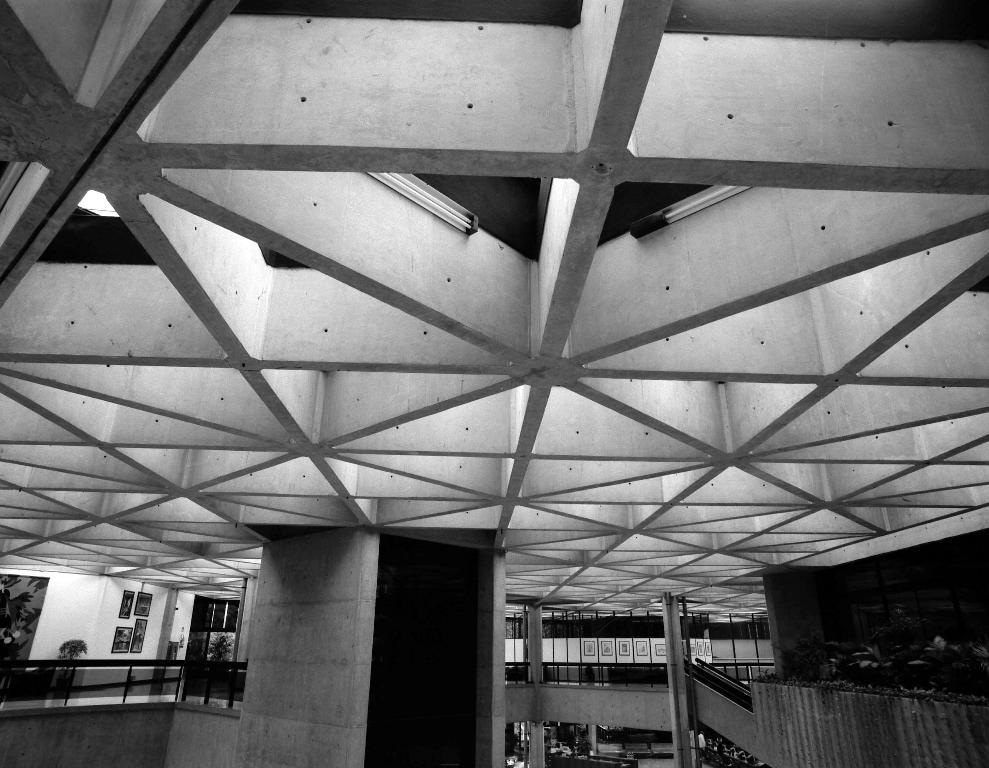Where was the image taken? The image was taken inside a building. What architectural feature can be seen in the image? There are stairs in the image. What decorative elements are present on the walls in the image? There are frames on the wall in the image. What type of lighting is visible in the image? There are lights at the top of the image. What safety feature is present in the image? There are railings visible in the image. What activity is being offered to the visitors in the image? There is no activity being offered to visitors in the image; it only shows stairs, frames on the wall, lights, and railings. 